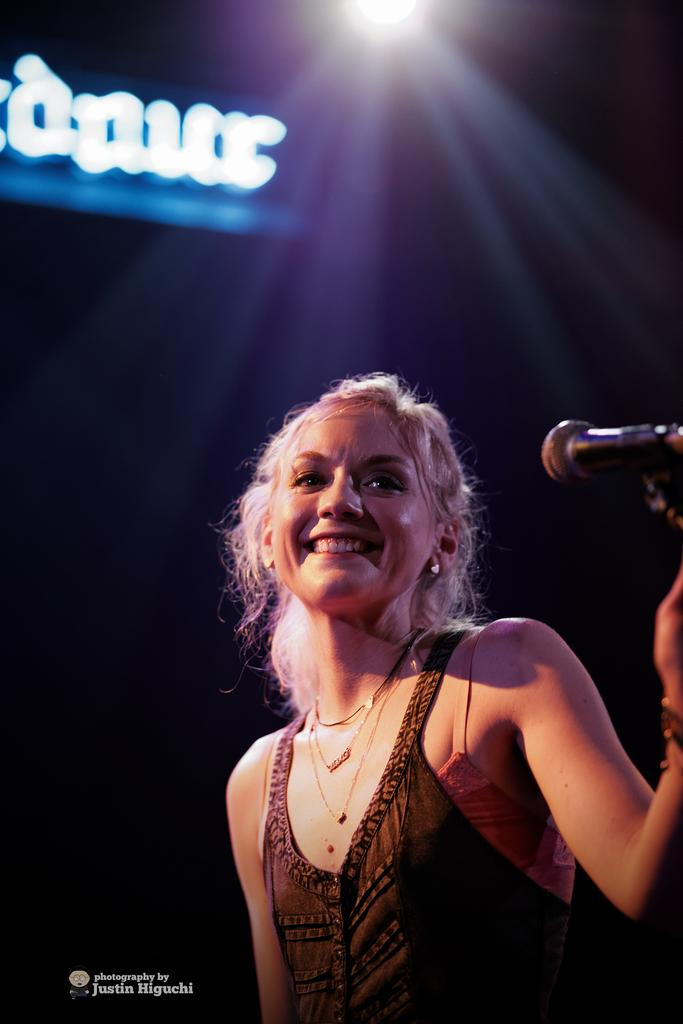Who is the main subject in the image? There is a woman in the image. What is the woman wearing? The woman is wearing a brown dress. What is the woman holding in the image? The woman is holding a microphone. Can you describe the lighting in the image? There is a light in the image. What is the color of the background in the image? The background of the image is black. What type of string is the woman using to hold the microphone in the image? There is no string visible in the image; the woman is holding the microphone with her hand. 